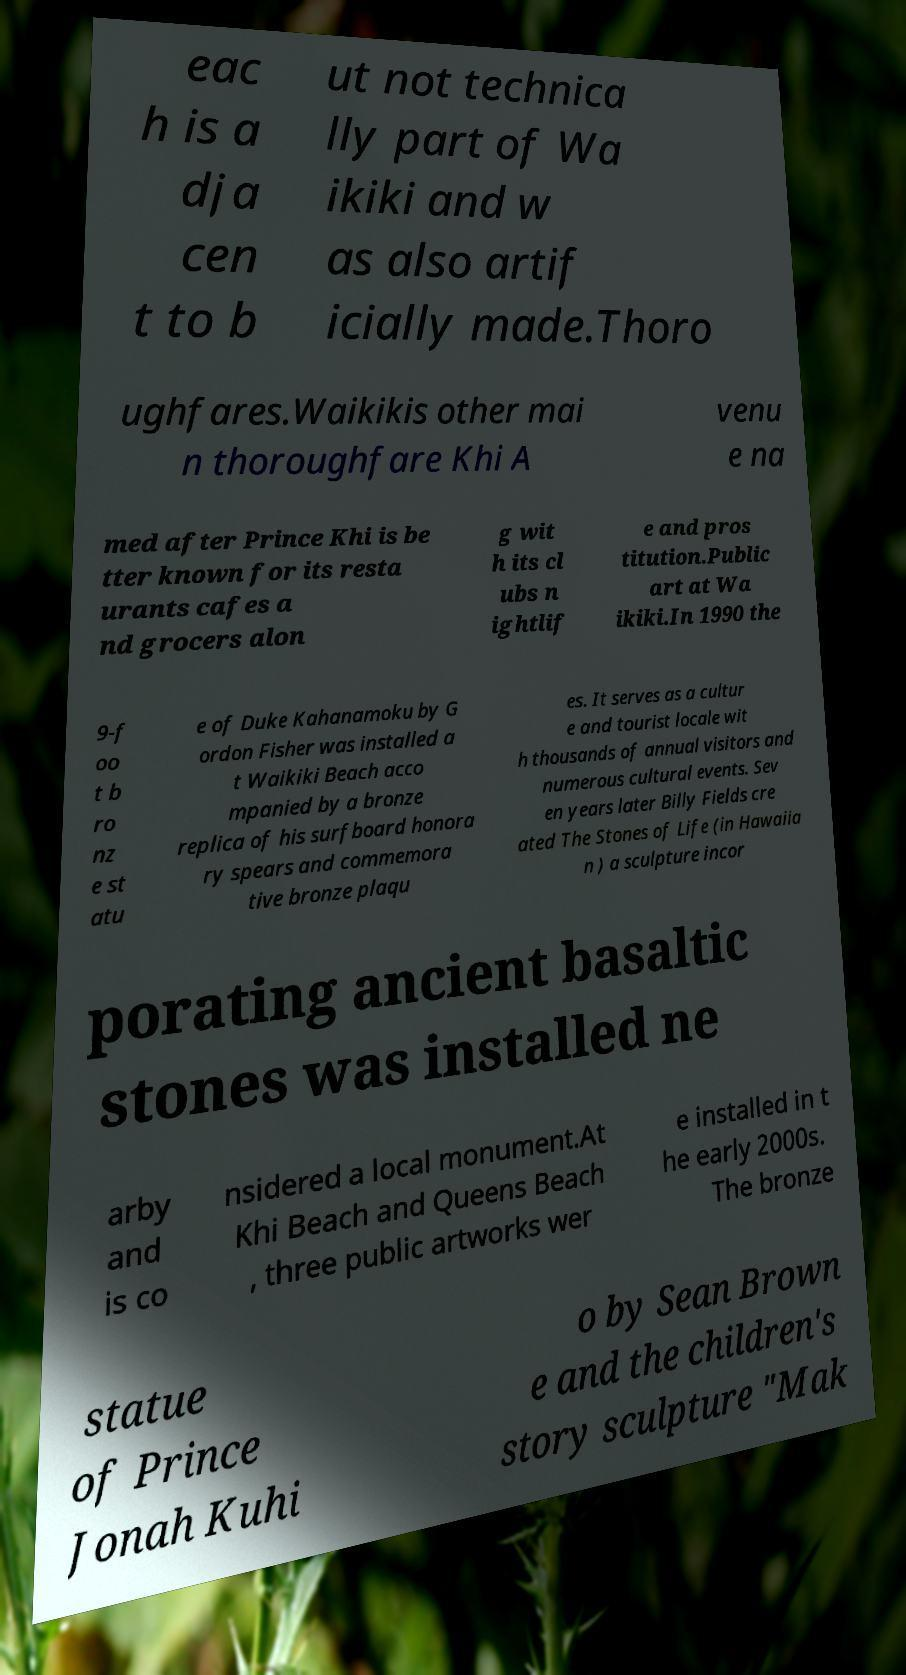Can you accurately transcribe the text from the provided image for me? eac h is a dja cen t to b ut not technica lly part of Wa ikiki and w as also artif icially made.Thoro ughfares.Waikikis other mai n thoroughfare Khi A venu e na med after Prince Khi is be tter known for its resta urants cafes a nd grocers alon g wit h its cl ubs n ightlif e and pros titution.Public art at Wa ikiki.In 1990 the 9-f oo t b ro nz e st atu e of Duke Kahanamoku by G ordon Fisher was installed a t Waikiki Beach acco mpanied by a bronze replica of his surfboard honora ry spears and commemora tive bronze plaqu es. It serves as a cultur e and tourist locale wit h thousands of annual visitors and numerous cultural events. Sev en years later Billy Fields cre ated The Stones of Life (in Hawaiia n ) a sculpture incor porating ancient basaltic stones was installed ne arby and is co nsidered a local monument.At Khi Beach and Queens Beach , three public artworks wer e installed in t he early 2000s. The bronze statue of Prince Jonah Kuhi o by Sean Brown e and the children's story sculpture "Mak 